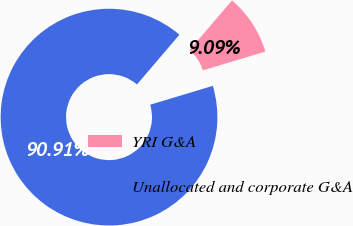<chart> <loc_0><loc_0><loc_500><loc_500><pie_chart><fcel>YRI G&A<fcel>Unallocated and corporate G&A<nl><fcel>9.09%<fcel>90.91%<nl></chart> 